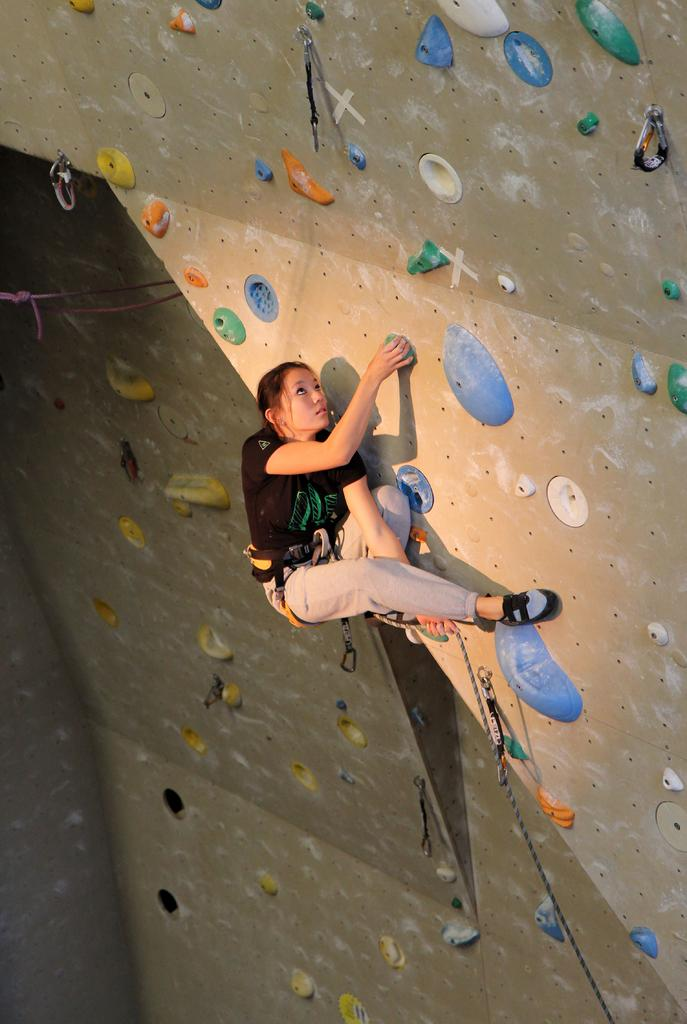Who is the main subject in the image? There is a girl in the image. What is the girl doing in the image? The girl is bouldering. What can be seen in the image that might be related to the girl's activity? There is a rope in the image. What is visible in the background of the image? There is a wall in the background of the image. Can you see a gun in the image? No, there is no gun present in the image. How many patches can be seen on the girl's clothing in the image? There are no patches visible on the girl's clothing in the image. 